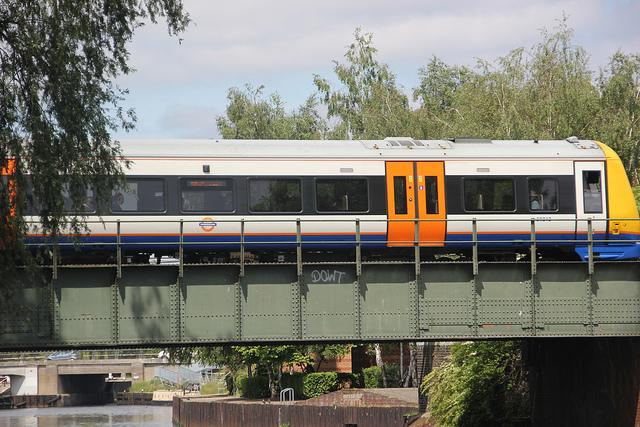The train gliding on what in order to move?

Choices:
A) rails
B) wheels
C) bridge
D) station rails 